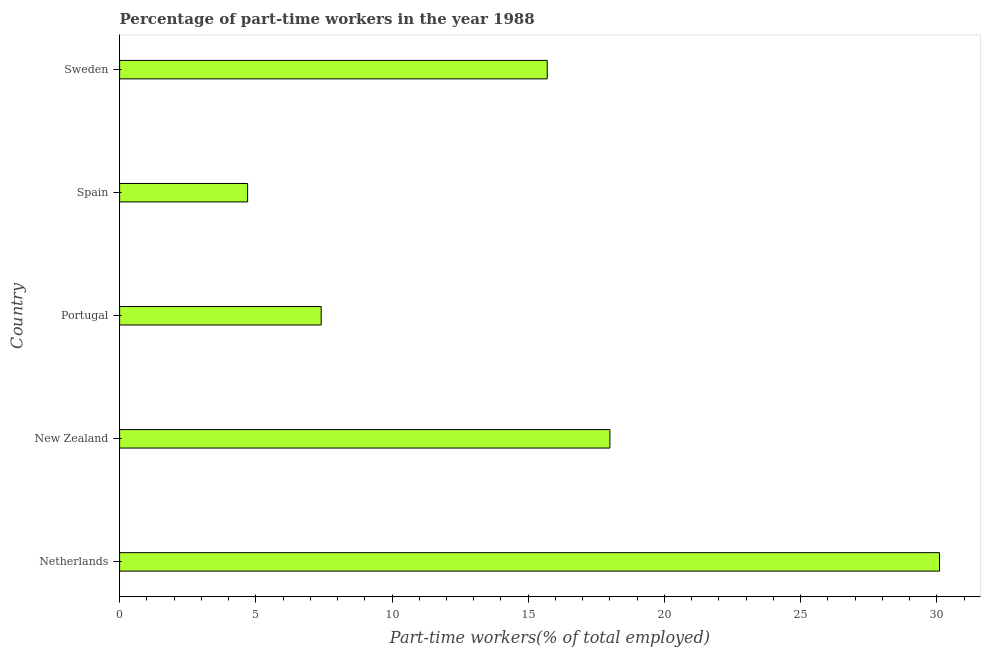What is the title of the graph?
Ensure brevity in your answer.  Percentage of part-time workers in the year 1988. What is the label or title of the X-axis?
Offer a very short reply. Part-time workers(% of total employed). What is the percentage of part-time workers in Portugal?
Give a very brief answer. 7.4. Across all countries, what is the maximum percentage of part-time workers?
Provide a succinct answer. 30.1. Across all countries, what is the minimum percentage of part-time workers?
Keep it short and to the point. 4.7. In which country was the percentage of part-time workers maximum?
Give a very brief answer. Netherlands. In which country was the percentage of part-time workers minimum?
Offer a terse response. Spain. What is the sum of the percentage of part-time workers?
Offer a very short reply. 75.9. What is the difference between the percentage of part-time workers in Netherlands and New Zealand?
Your answer should be very brief. 12.1. What is the average percentage of part-time workers per country?
Your answer should be compact. 15.18. What is the median percentage of part-time workers?
Keep it short and to the point. 15.7. In how many countries, is the percentage of part-time workers greater than 18 %?
Keep it short and to the point. 1. What is the ratio of the percentage of part-time workers in Portugal to that in Spain?
Ensure brevity in your answer.  1.57. What is the difference between the highest and the second highest percentage of part-time workers?
Your response must be concise. 12.1. Is the sum of the percentage of part-time workers in Portugal and Spain greater than the maximum percentage of part-time workers across all countries?
Provide a succinct answer. No. What is the difference between the highest and the lowest percentage of part-time workers?
Provide a short and direct response. 25.4. Are all the bars in the graph horizontal?
Offer a terse response. Yes. What is the difference between two consecutive major ticks on the X-axis?
Make the answer very short. 5. Are the values on the major ticks of X-axis written in scientific E-notation?
Give a very brief answer. No. What is the Part-time workers(% of total employed) of Netherlands?
Make the answer very short. 30.1. What is the Part-time workers(% of total employed) of Portugal?
Make the answer very short. 7.4. What is the Part-time workers(% of total employed) of Spain?
Offer a very short reply. 4.7. What is the Part-time workers(% of total employed) in Sweden?
Keep it short and to the point. 15.7. What is the difference between the Part-time workers(% of total employed) in Netherlands and Portugal?
Your answer should be very brief. 22.7. What is the difference between the Part-time workers(% of total employed) in Netherlands and Spain?
Give a very brief answer. 25.4. What is the difference between the Part-time workers(% of total employed) in Netherlands and Sweden?
Make the answer very short. 14.4. What is the difference between the Part-time workers(% of total employed) in New Zealand and Sweden?
Your answer should be very brief. 2.3. What is the difference between the Part-time workers(% of total employed) in Spain and Sweden?
Give a very brief answer. -11. What is the ratio of the Part-time workers(% of total employed) in Netherlands to that in New Zealand?
Offer a terse response. 1.67. What is the ratio of the Part-time workers(% of total employed) in Netherlands to that in Portugal?
Keep it short and to the point. 4.07. What is the ratio of the Part-time workers(% of total employed) in Netherlands to that in Spain?
Your answer should be compact. 6.4. What is the ratio of the Part-time workers(% of total employed) in Netherlands to that in Sweden?
Provide a succinct answer. 1.92. What is the ratio of the Part-time workers(% of total employed) in New Zealand to that in Portugal?
Your response must be concise. 2.43. What is the ratio of the Part-time workers(% of total employed) in New Zealand to that in Spain?
Keep it short and to the point. 3.83. What is the ratio of the Part-time workers(% of total employed) in New Zealand to that in Sweden?
Provide a short and direct response. 1.15. What is the ratio of the Part-time workers(% of total employed) in Portugal to that in Spain?
Make the answer very short. 1.57. What is the ratio of the Part-time workers(% of total employed) in Portugal to that in Sweden?
Offer a very short reply. 0.47. What is the ratio of the Part-time workers(% of total employed) in Spain to that in Sweden?
Keep it short and to the point. 0.3. 